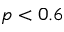Convert formula to latex. <formula><loc_0><loc_0><loc_500><loc_500>p < 0 . 6</formula> 